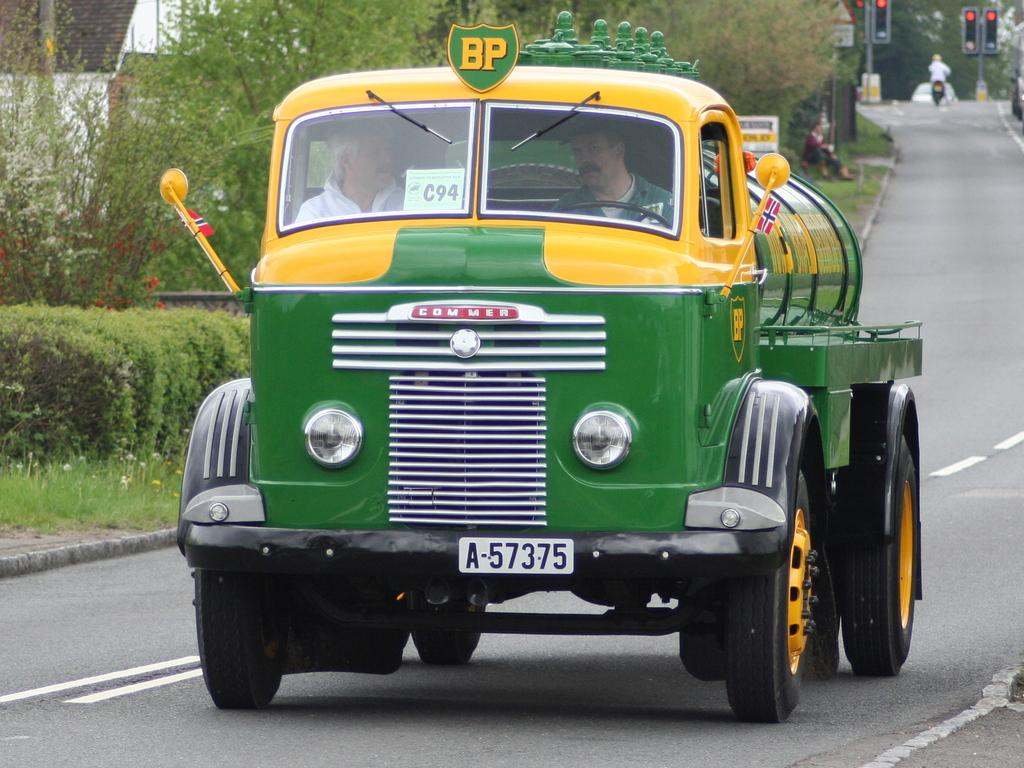<image>
Relay a brief, clear account of the picture shown. A BP truck number C94 drives down the road. 